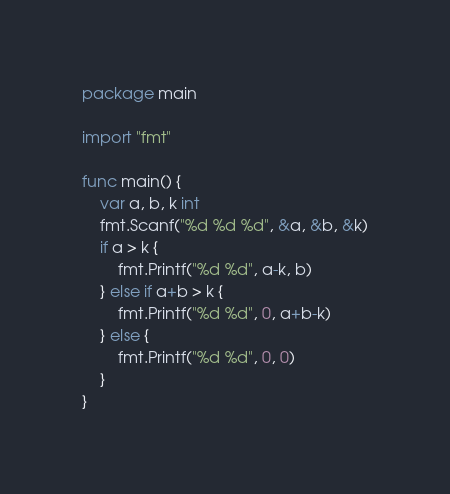Convert code to text. <code><loc_0><loc_0><loc_500><loc_500><_Go_>package main

import "fmt"

func main() {
	var a, b, k int
	fmt.Scanf("%d %d %d", &a, &b, &k)
	if a > k {
		fmt.Printf("%d %d", a-k, b)
	} else if a+b > k {
		fmt.Printf("%d %d", 0, a+b-k)
	} else {
		fmt.Printf("%d %d", 0, 0)
	}
}
</code> 